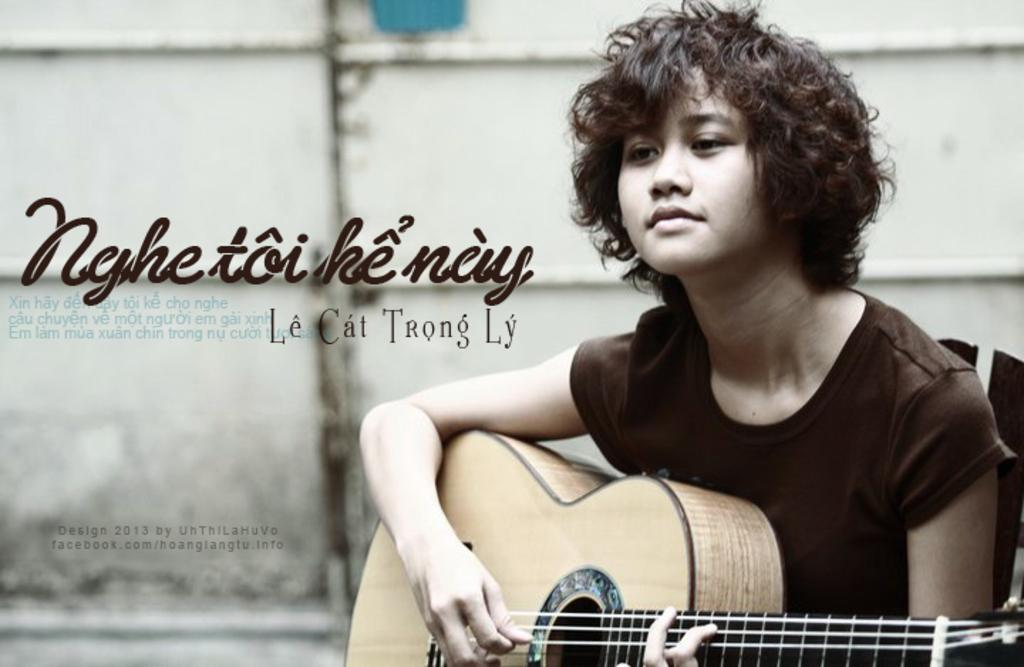What is the person in the image doing? There is a person sitting in the image. What is the person holding in the image? The person is holding a yellow-colored music instrument. What can be seen in the background of the image? There is a white-colored wall in the background of the image. What verse is the person reciting from the book in the image? There is no book present in the image, and therefore no verse can be recited. 